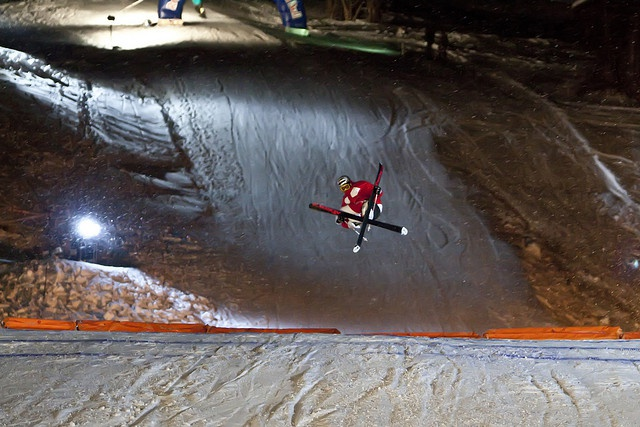Describe the objects in this image and their specific colors. I can see people in black, maroon, brown, and gray tones and skis in black, gray, maroon, and white tones in this image. 